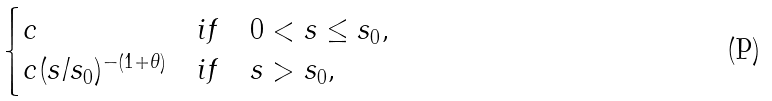<formula> <loc_0><loc_0><loc_500><loc_500>\begin{cases} c & i f \quad 0 < s \leq s _ { 0 } , \\ c ( s / s _ { 0 } ) ^ { - \left ( 1 + \theta \right ) } & i f \quad s > s _ { 0 } , \end{cases}</formula> 